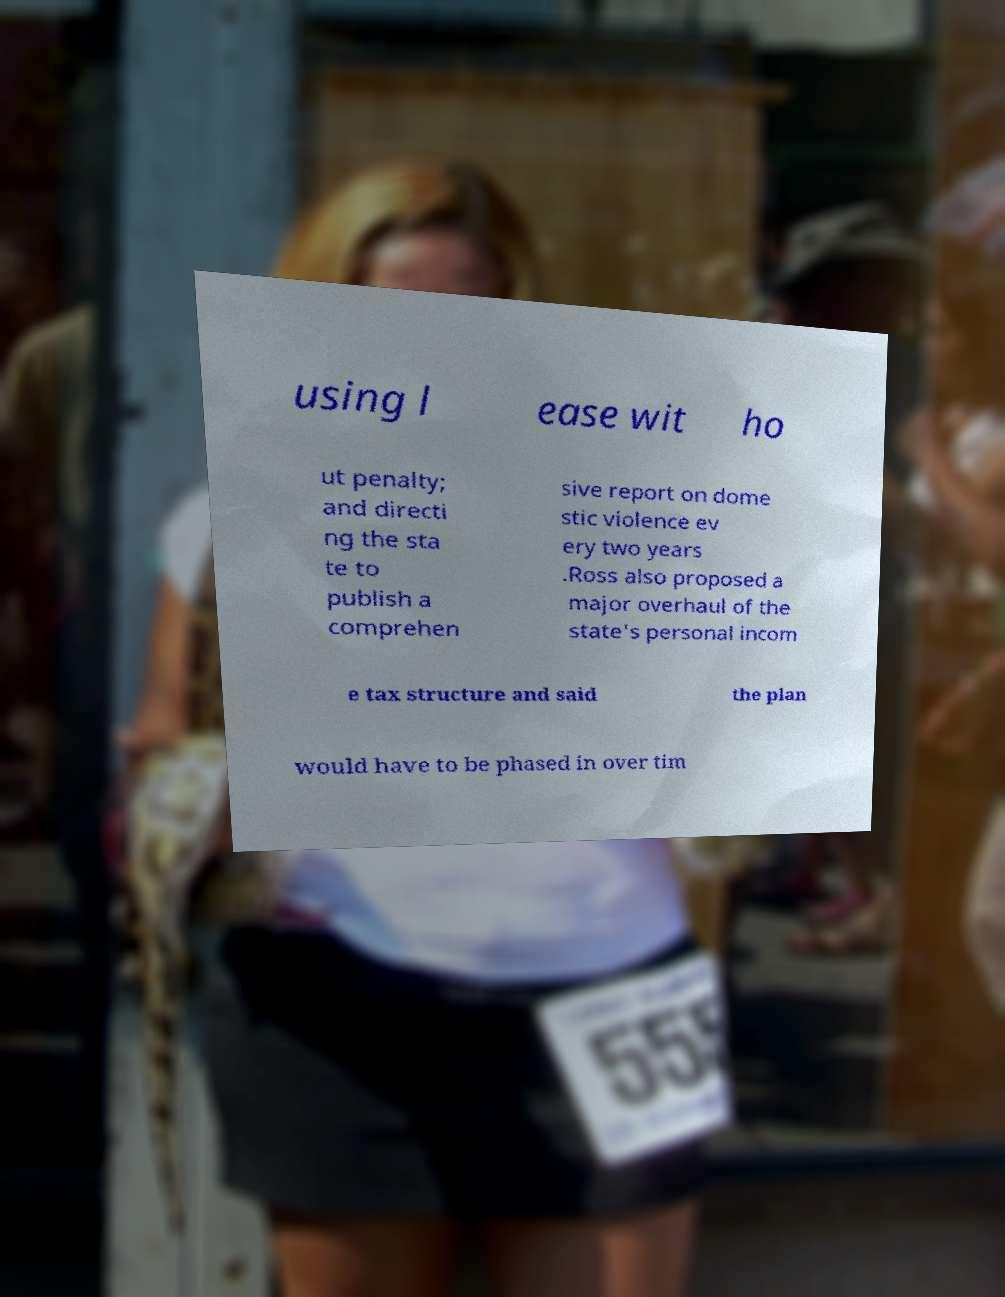For documentation purposes, I need the text within this image transcribed. Could you provide that? using l ease wit ho ut penalty; and directi ng the sta te to publish a comprehen sive report on dome stic violence ev ery two years .Ross also proposed a major overhaul of the state's personal incom e tax structure and said the plan would have to be phased in over tim 